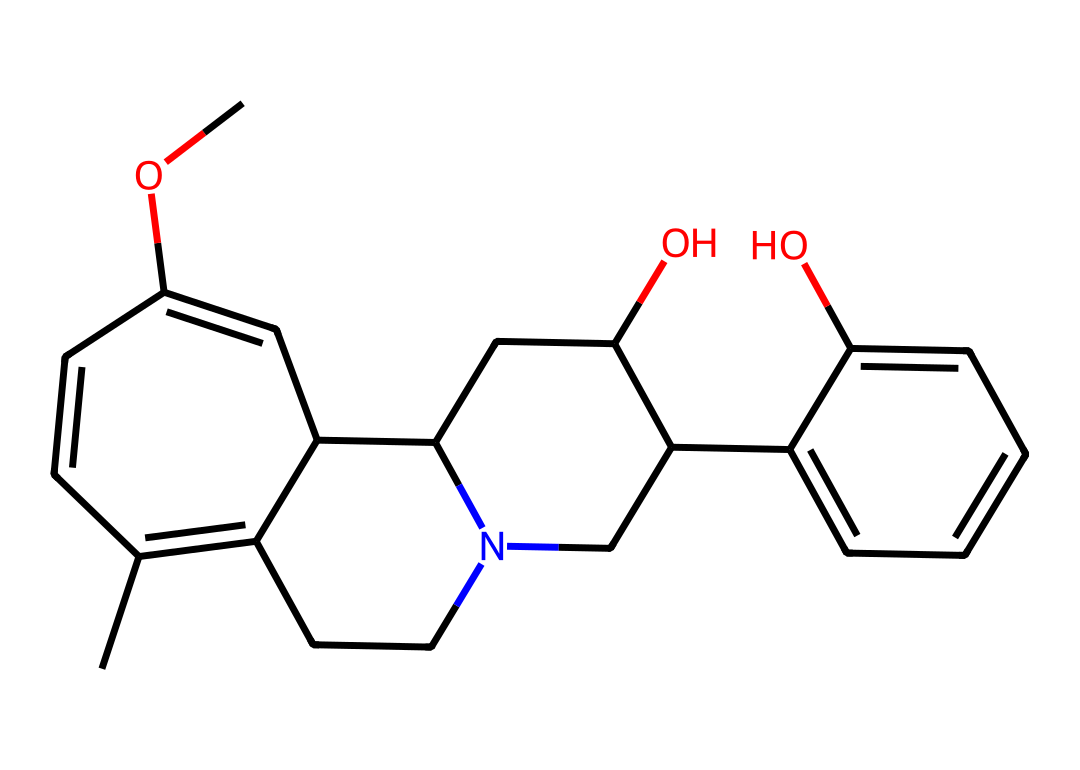How many rings are present in the structure of quinine? The SMILES representation indicates that there are multiple cyclic structures; counting the distinct rings shows that there are three rings present.
Answer: three What functional groups can be identified in quinine? Analyzing the structure reveals multiple functional groups, including an alcohol (-OH) and an ether (-O-), indicating the presence of hydroxyl and ether functionalities.
Answer: alcohol and ether What elements are the primary components of quinine? By examining the SMILES structure, the elements present are carbon (C), hydrogen (H), nitrogen (N), and oxygen (O).
Answer: carbon, hydrogen, nitrogen, oxygen Which bond type is primarily responsible for geometrical isomerism in quinine? The presence of double bonds in the ring structures allows for the formation of cis and trans configurations, which are responsible for geometrical isomerism.
Answer: double bond How many geometric isomers could quinine potentially have? Considering the structure features two double bonds that can exhibit cis/trans configurations, quinine can potentially have multiple geometric isomers, but the specific count can depend on the configuration of the double bonds; generally, it is limited to a few distinct forms.
Answer: multiple What part of the structure contributes to the antimalarial activity of quinine? Quinine's antimalarial activity is largely attributed to the presence of the quinoline structure, which includes the nitrogen in the aromatic ring; this structure interacts effectively with the malaria parasite.
Answer: quinoline structure 